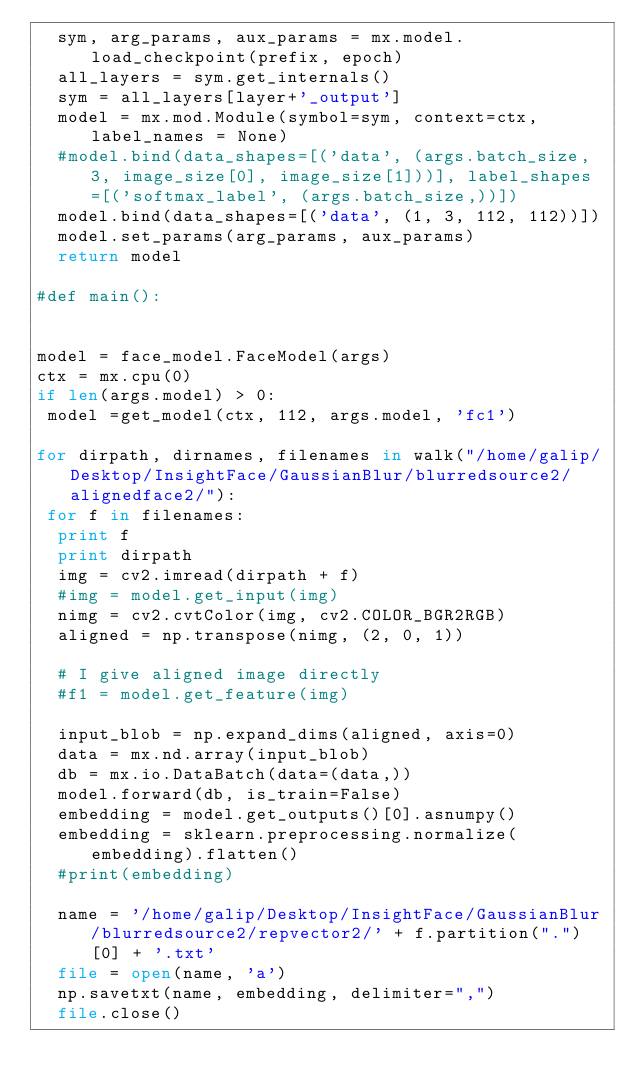<code> <loc_0><loc_0><loc_500><loc_500><_Python_>  sym, arg_params, aux_params = mx.model.load_checkpoint(prefix, epoch)
  all_layers = sym.get_internals()
  sym = all_layers[layer+'_output']
  model = mx.mod.Module(symbol=sym, context=ctx, label_names = None)
  #model.bind(data_shapes=[('data', (args.batch_size, 3, image_size[0], image_size[1]))], label_shapes=[('softmax_label', (args.batch_size,))])
  model.bind(data_shapes=[('data', (1, 3, 112, 112))])
  model.set_params(arg_params, aux_params)
  return model

#def main():


model = face_model.FaceModel(args)
ctx = mx.cpu(0)
if len(args.model) > 0:
 model =get_model(ctx, 112, args.model, 'fc1')

for dirpath, dirnames, filenames in walk("/home/galip/Desktop/InsightFace/GaussianBlur/blurredsource2/alignedface2/"):
 for f in filenames:
  print f
  print dirpath
  img = cv2.imread(dirpath + f)
  #img = model.get_input(img)
  nimg = cv2.cvtColor(img, cv2.COLOR_BGR2RGB)
  aligned = np.transpose(nimg, (2, 0, 1))

  # I give aligned image directly
  #f1 = model.get_feature(img)

  input_blob = np.expand_dims(aligned, axis=0)
  data = mx.nd.array(input_blob)
  db = mx.io.DataBatch(data=(data,))
  model.forward(db, is_train=False)
  embedding = model.get_outputs()[0].asnumpy()
  embedding = sklearn.preprocessing.normalize(embedding).flatten()
  #print(embedding)

  name = '/home/galip/Desktop/InsightFace/GaussianBlur/blurredsource2/repvector2/' + f.partition(".")[0] + '.txt'
  file = open(name, 'a')
  np.savetxt(name, embedding, delimiter=",")
  file.close()
</code> 